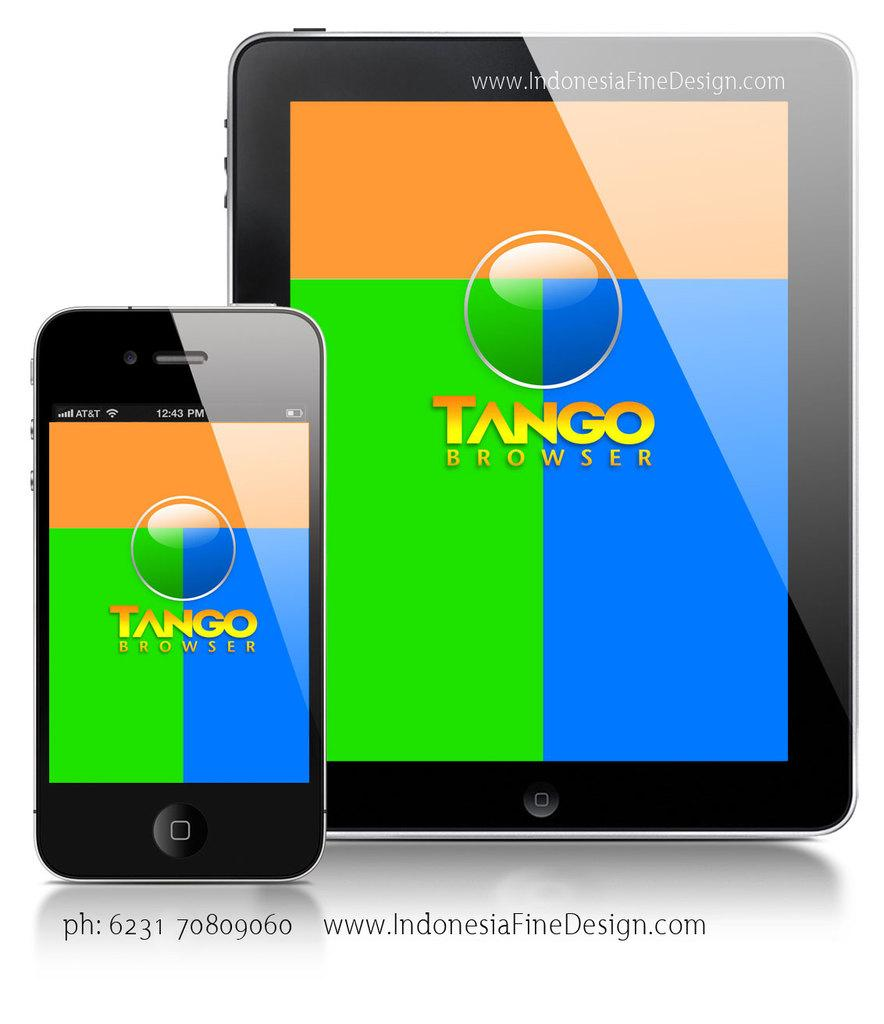Provide a one-sentence caption for the provided image. A phone showing the Tango Browser app is right next to a tablet showing the same app. 